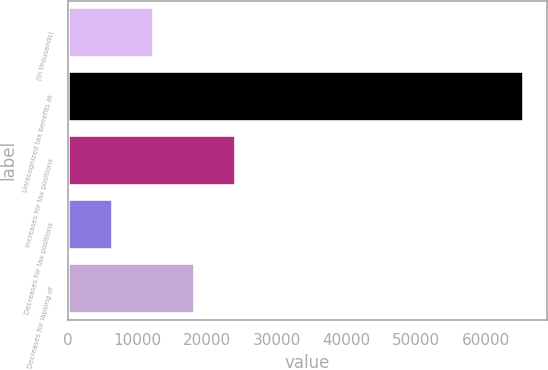Convert chart. <chart><loc_0><loc_0><loc_500><loc_500><bar_chart><fcel>(In thousands)<fcel>Unrecognized tax benefits at<fcel>Increases for tax positions<fcel>Decreases for tax positions<fcel>Decreases for lapsing of<nl><fcel>12355.8<fcel>65396.4<fcel>24160.6<fcel>6453.4<fcel>18258.2<nl></chart> 